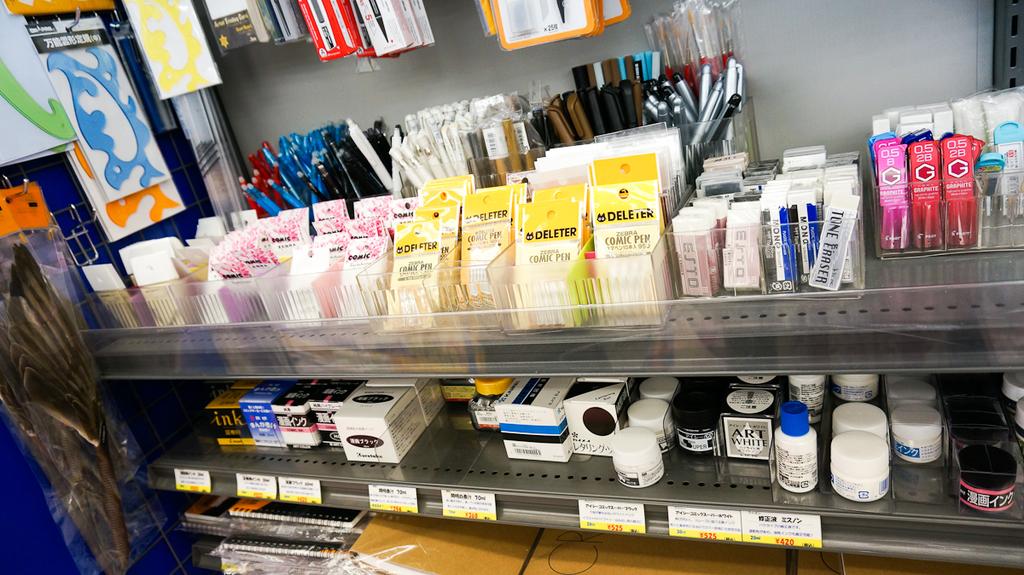What kind of products are being sold here?
Give a very brief answer. Art. 